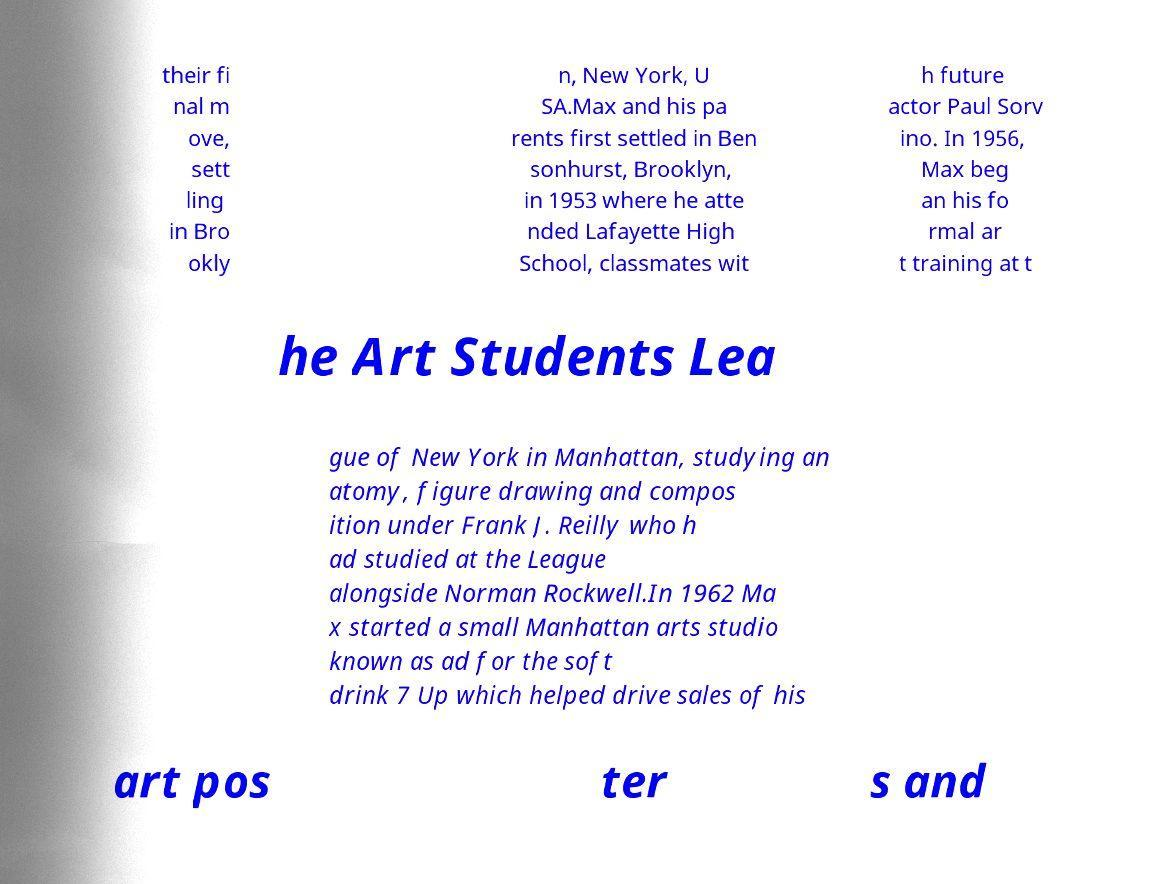Please read and relay the text visible in this image. What does it say? their fi nal m ove, sett ling in Bro okly n, New York, U SA.Max and his pa rents first settled in Ben sonhurst, Brooklyn, in 1953 where he atte nded Lafayette High School, classmates wit h future actor Paul Sorv ino. In 1956, Max beg an his fo rmal ar t training at t he Art Students Lea gue of New York in Manhattan, studying an atomy, figure drawing and compos ition under Frank J. Reilly who h ad studied at the League alongside Norman Rockwell.In 1962 Ma x started a small Manhattan arts studio known as ad for the soft drink 7 Up which helped drive sales of his art pos ter s and 